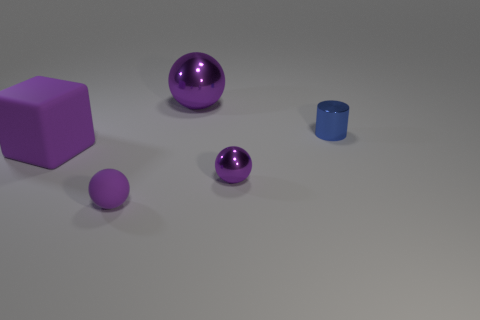Add 3 big brown cylinders. How many objects exist? 8 Subtract all blocks. How many objects are left? 4 Add 3 small purple balls. How many small purple balls are left? 5 Add 5 matte cubes. How many matte cubes exist? 6 Subtract 0 brown spheres. How many objects are left? 5 Subtract all big purple metallic spheres. Subtract all purple objects. How many objects are left? 0 